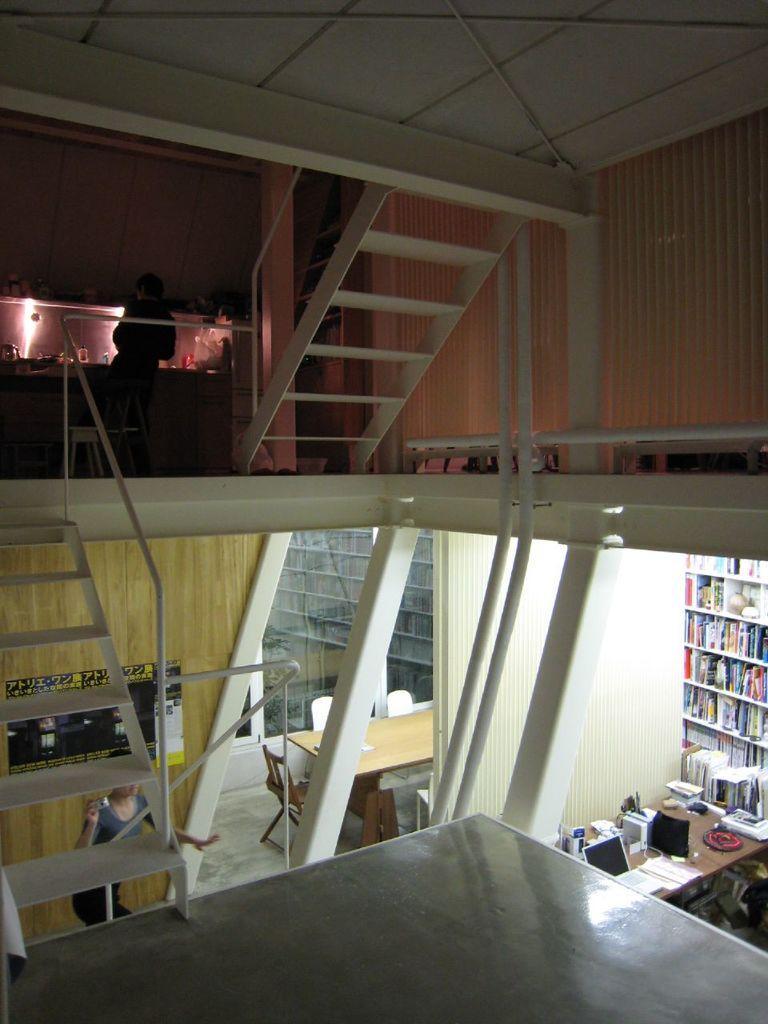Could you give a brief overview of what you see in this image? In this image, we can see some stairs and the railing. We can see the ground. There are a few people. We can see some tables. Among them, we can see some objects like a laptop on one of the tables. We can see some chairs. We can see some shelves with objects. We can see the wall with a poster. We can see some glass. We can see the roof. We can see some poles. 